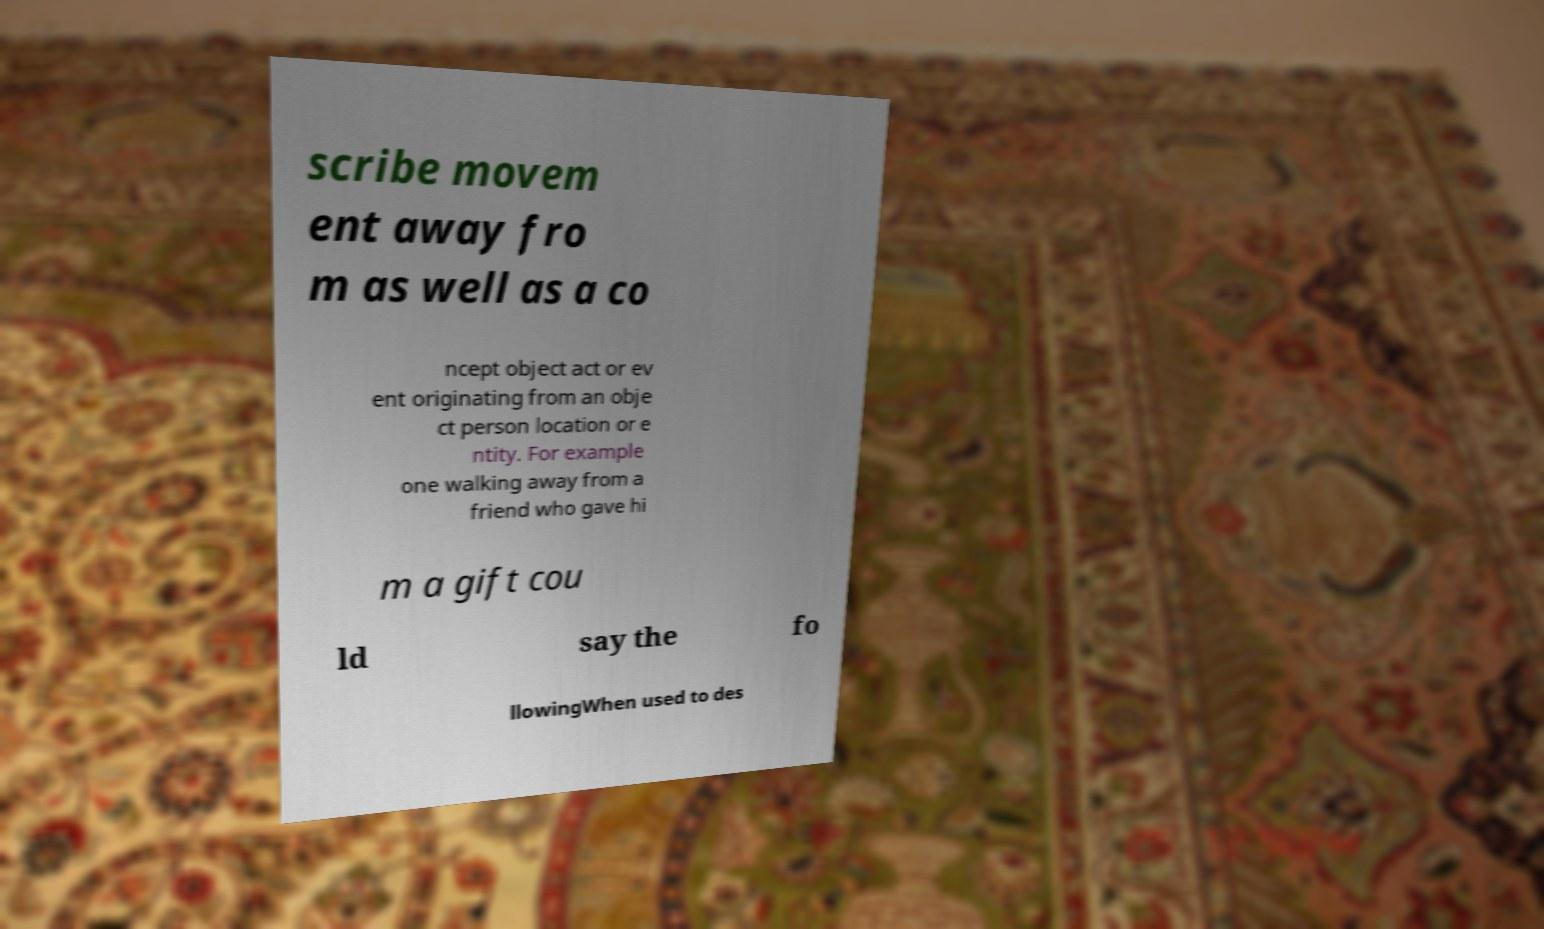Please identify and transcribe the text found in this image. scribe movem ent away fro m as well as a co ncept object act or ev ent originating from an obje ct person location or e ntity. For example one walking away from a friend who gave hi m a gift cou ld say the fo llowingWhen used to des 